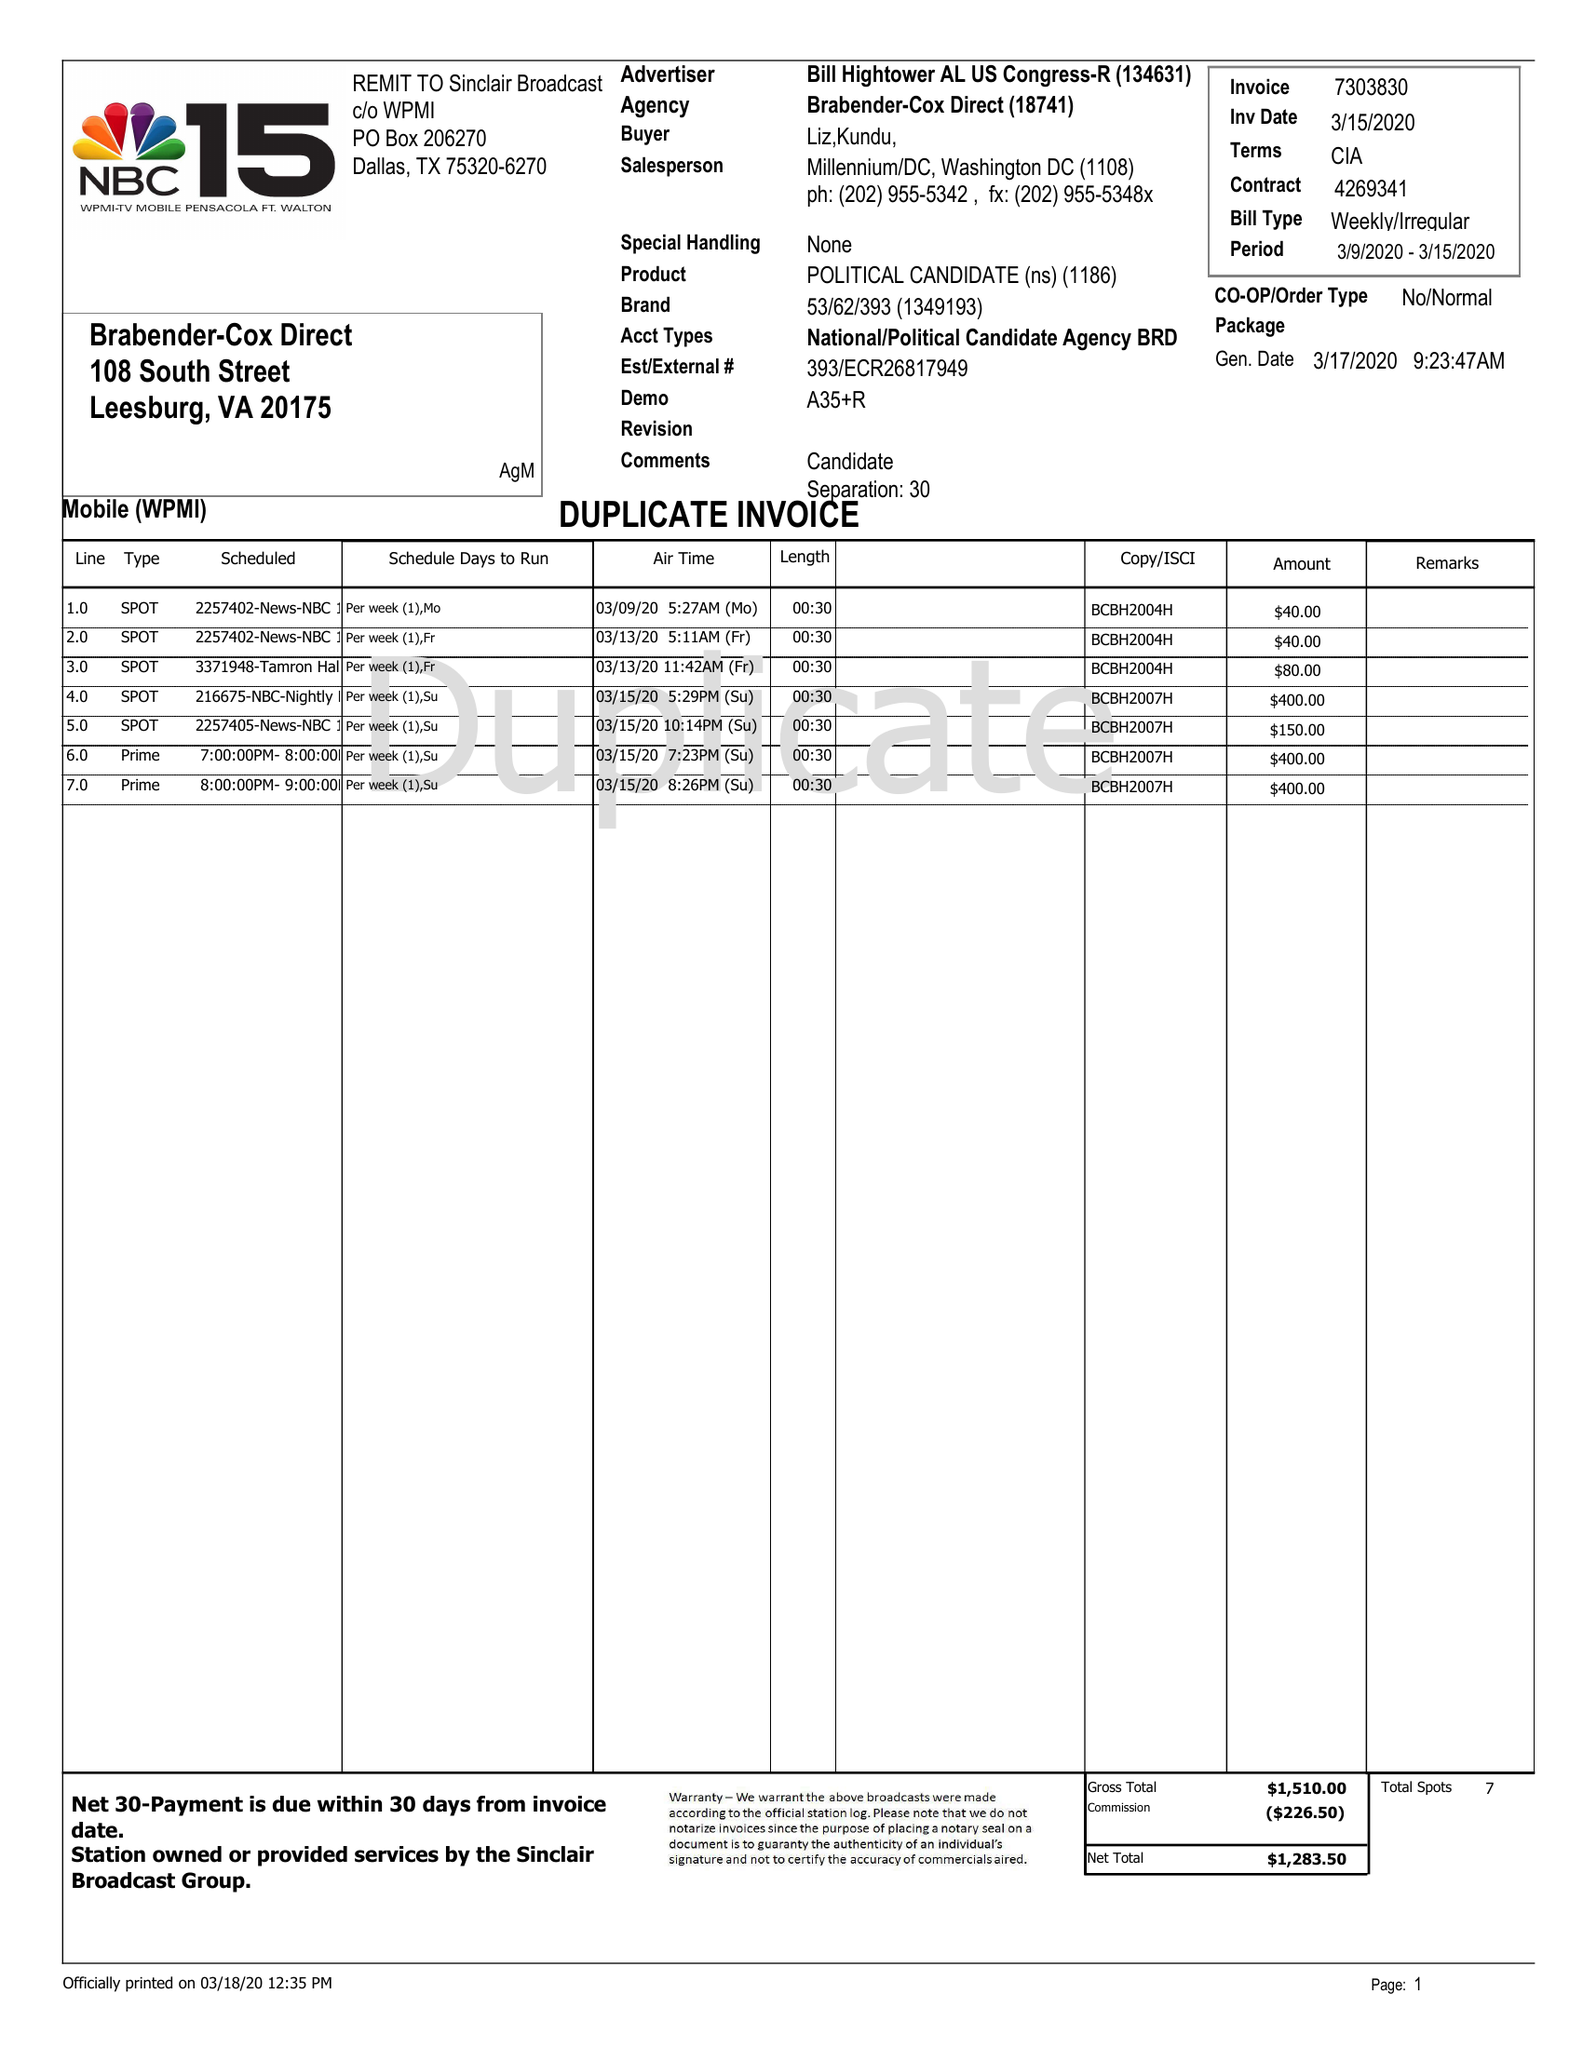What is the value for the advertiser?
Answer the question using a single word or phrase. BILL HIGHTOWER AL US CONGRESS-R 